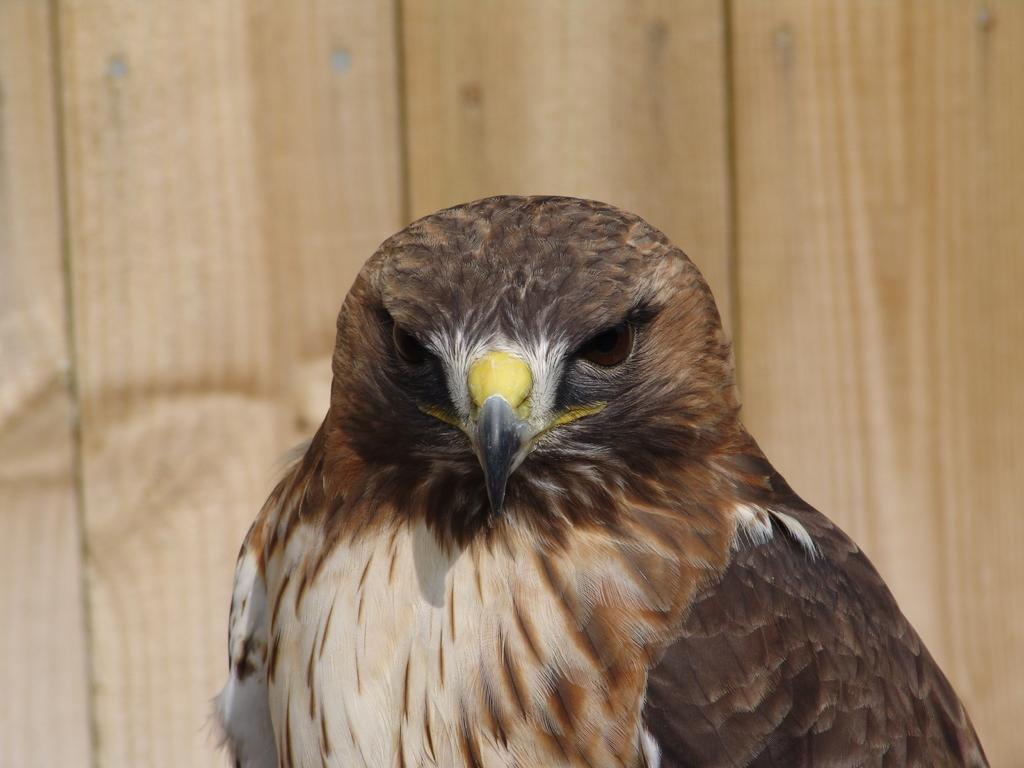What type of animal is in the image? There is an owl in the image. What is the owl doing in the image? The owl appears to be standing. What can be seen in the background of the image? There are wooden objects in the background of the image. What toy does the father give to the child in the image? There is no father, child, or toy present in the image; it only features an owl standing amidst wooden objects in the background. 